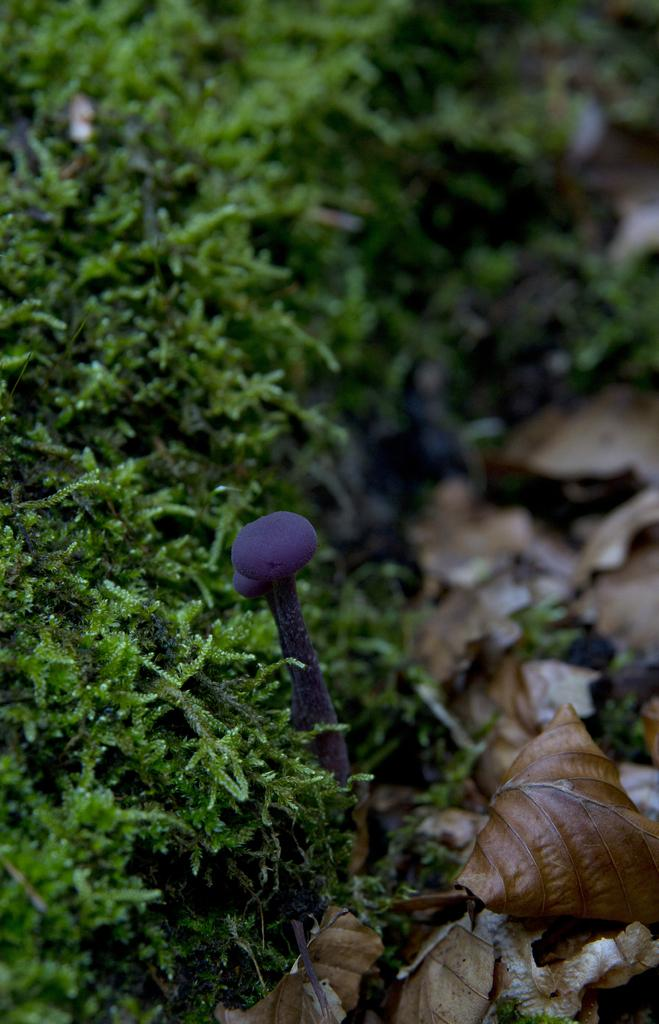What type of plant can be seen in the picture? There is a mushroom in the picture. What other natural elements are present in the image? There are leaves and grass in the picture. How much debt does the sister owe in the image? There is no mention of a sister or debt in the image, as it features a mushroom, leaves, and grass. 